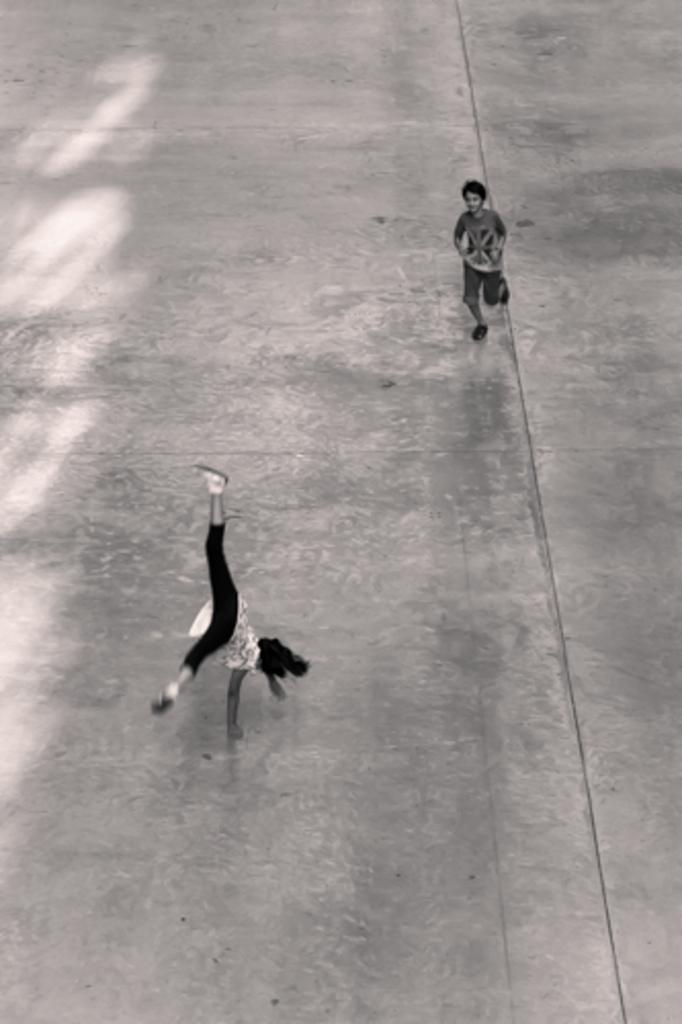What is the color scheme of the image? The image is black and white. What is one of the persons in the image doing? There is a person running in the image. What is the other person in the image doing? The other person is performing a stunt in the image. Where are the persons located in the image? Both persons are on a path. What is the size of the father in the image? There is no father present in the image, and therefore no size can be determined. 